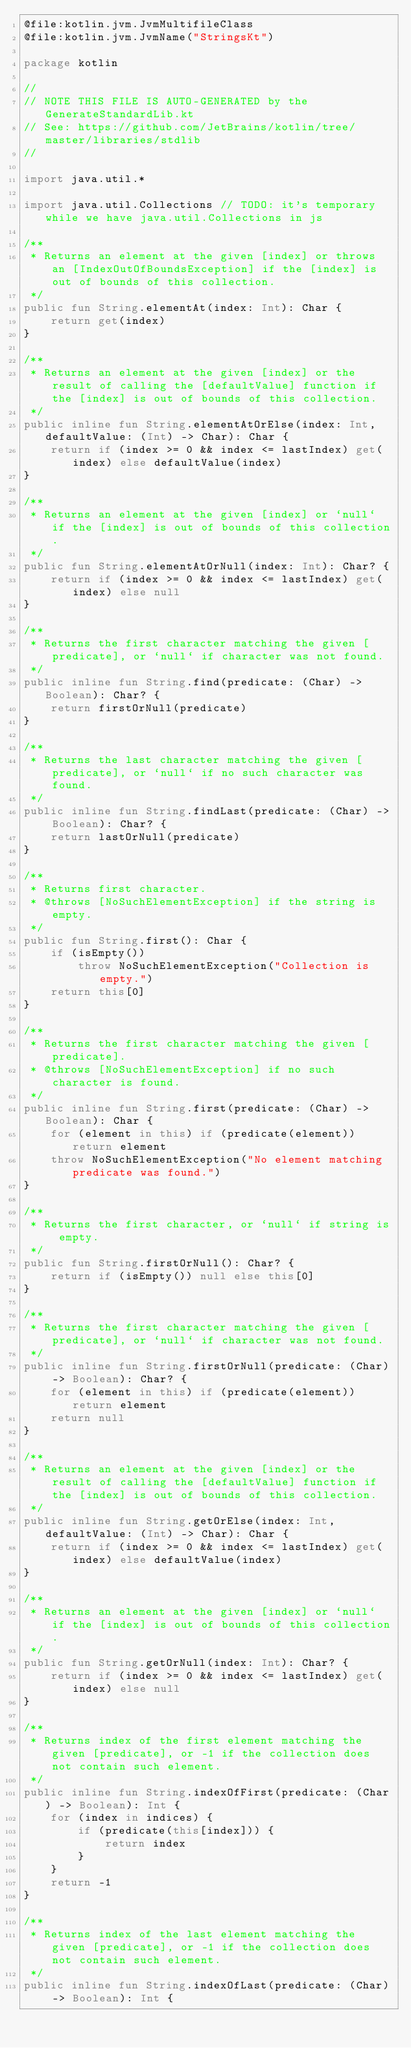<code> <loc_0><loc_0><loc_500><loc_500><_Kotlin_>@file:kotlin.jvm.JvmMultifileClass
@file:kotlin.jvm.JvmName("StringsKt")

package kotlin

//
// NOTE THIS FILE IS AUTO-GENERATED by the GenerateStandardLib.kt
// See: https://github.com/JetBrains/kotlin/tree/master/libraries/stdlib
//

import java.util.*

import java.util.Collections // TODO: it's temporary while we have java.util.Collections in js

/**
 * Returns an element at the given [index] or throws an [IndexOutOfBoundsException] if the [index] is out of bounds of this collection.
 */
public fun String.elementAt(index: Int): Char {
    return get(index)
}

/**
 * Returns an element at the given [index] or the result of calling the [defaultValue] function if the [index] is out of bounds of this collection.
 */
public inline fun String.elementAtOrElse(index: Int, defaultValue: (Int) -> Char): Char {
    return if (index >= 0 && index <= lastIndex) get(index) else defaultValue(index)
}

/**
 * Returns an element at the given [index] or `null` if the [index] is out of bounds of this collection.
 */
public fun String.elementAtOrNull(index: Int): Char? {
    return if (index >= 0 && index <= lastIndex) get(index) else null
}

/**
 * Returns the first character matching the given [predicate], or `null` if character was not found.
 */
public inline fun String.find(predicate: (Char) -> Boolean): Char? {
    return firstOrNull(predicate)
}

/**
 * Returns the last character matching the given [predicate], or `null` if no such character was found.
 */
public inline fun String.findLast(predicate: (Char) -> Boolean): Char? {
    return lastOrNull(predicate)
}

/**
 * Returns first character.
 * @throws [NoSuchElementException] if the string is empty.
 */
public fun String.first(): Char {
    if (isEmpty())
        throw NoSuchElementException("Collection is empty.")
    return this[0]
}

/**
 * Returns the first character matching the given [predicate].
 * @throws [NoSuchElementException] if no such character is found.
 */
public inline fun String.first(predicate: (Char) -> Boolean): Char {
    for (element in this) if (predicate(element)) return element
    throw NoSuchElementException("No element matching predicate was found.")
}

/**
 * Returns the first character, or `null` if string is empty.
 */
public fun String.firstOrNull(): Char? {
    return if (isEmpty()) null else this[0]
}

/**
 * Returns the first character matching the given [predicate], or `null` if character was not found.
 */
public inline fun String.firstOrNull(predicate: (Char) -> Boolean): Char? {
    for (element in this) if (predicate(element)) return element
    return null
}

/**
 * Returns an element at the given [index] or the result of calling the [defaultValue] function if the [index] is out of bounds of this collection.
 */
public inline fun String.getOrElse(index: Int, defaultValue: (Int) -> Char): Char {
    return if (index >= 0 && index <= lastIndex) get(index) else defaultValue(index)
}

/**
 * Returns an element at the given [index] or `null` if the [index] is out of bounds of this collection.
 */
public fun String.getOrNull(index: Int): Char? {
    return if (index >= 0 && index <= lastIndex) get(index) else null
}

/**
 * Returns index of the first element matching the given [predicate], or -1 if the collection does not contain such element.
 */
public inline fun String.indexOfFirst(predicate: (Char) -> Boolean): Int {
    for (index in indices) {
        if (predicate(this[index])) {
            return index
        }
    }
    return -1
}

/**
 * Returns index of the last element matching the given [predicate], or -1 if the collection does not contain such element.
 */
public inline fun String.indexOfLast(predicate: (Char) -> Boolean): Int {</code> 